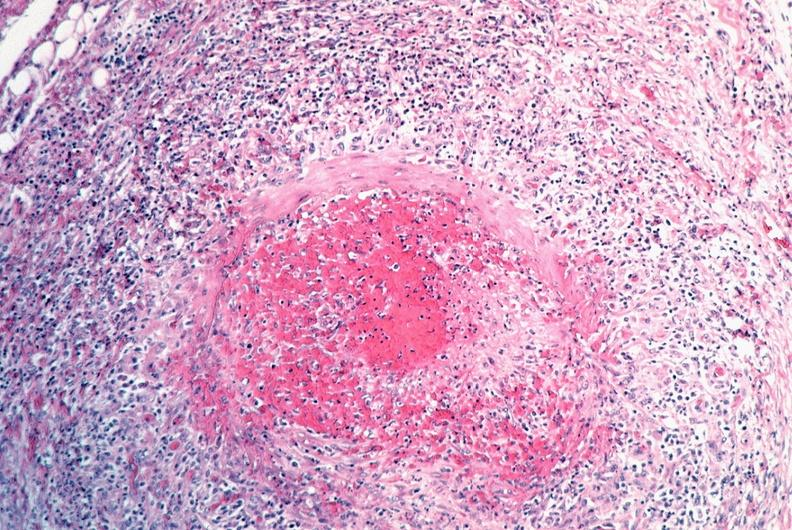what is present?
Answer the question using a single word or phrase. Vasculature 